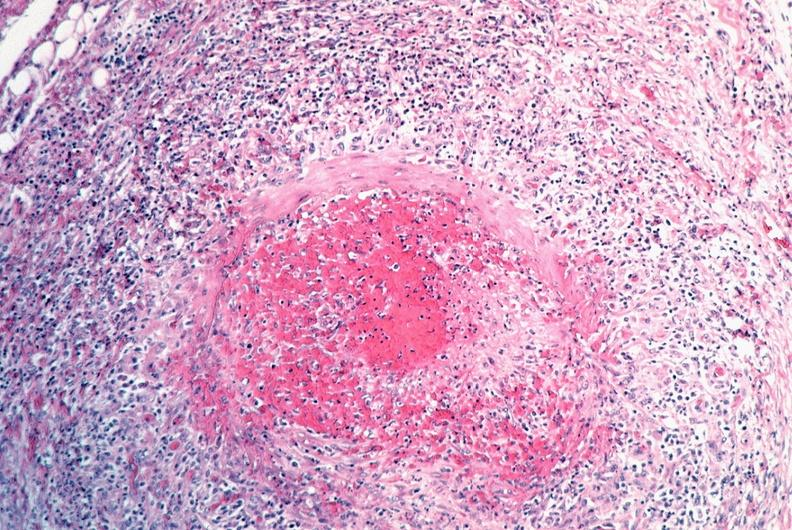what is present?
Answer the question using a single word or phrase. Vasculature 